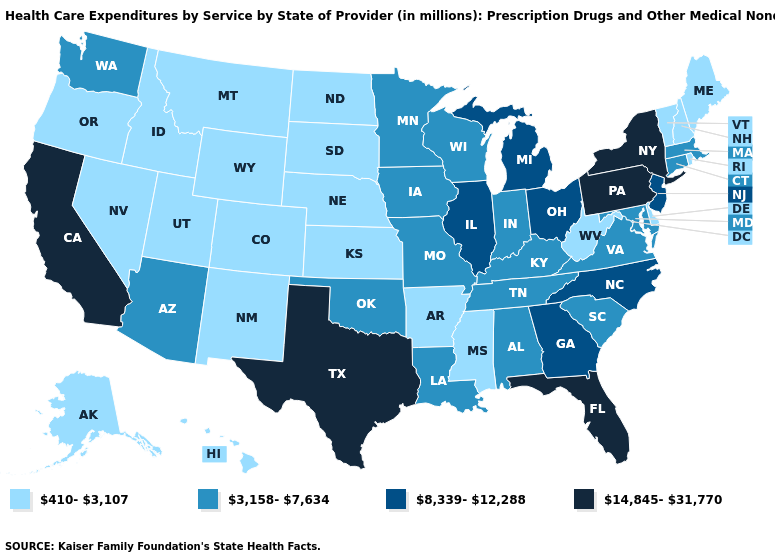Does Ohio have the lowest value in the USA?
Be succinct. No. What is the value of Mississippi?
Short answer required. 410-3,107. Which states have the highest value in the USA?
Give a very brief answer. California, Florida, New York, Pennsylvania, Texas. Name the states that have a value in the range 410-3,107?
Write a very short answer. Alaska, Arkansas, Colorado, Delaware, Hawaii, Idaho, Kansas, Maine, Mississippi, Montana, Nebraska, Nevada, New Hampshire, New Mexico, North Dakota, Oregon, Rhode Island, South Dakota, Utah, Vermont, West Virginia, Wyoming. Name the states that have a value in the range 8,339-12,288?
Keep it brief. Georgia, Illinois, Michigan, New Jersey, North Carolina, Ohio. Name the states that have a value in the range 8,339-12,288?
Short answer required. Georgia, Illinois, Michigan, New Jersey, North Carolina, Ohio. What is the value of Ohio?
Give a very brief answer. 8,339-12,288. Does Missouri have the same value as Alabama?
Keep it brief. Yes. Name the states that have a value in the range 8,339-12,288?
Concise answer only. Georgia, Illinois, Michigan, New Jersey, North Carolina, Ohio. Does Virginia have a higher value than Missouri?
Keep it brief. No. What is the highest value in the Northeast ?
Give a very brief answer. 14,845-31,770. What is the value of Michigan?
Short answer required. 8,339-12,288. What is the lowest value in the USA?
Write a very short answer. 410-3,107. What is the highest value in the USA?
Concise answer only. 14,845-31,770. 